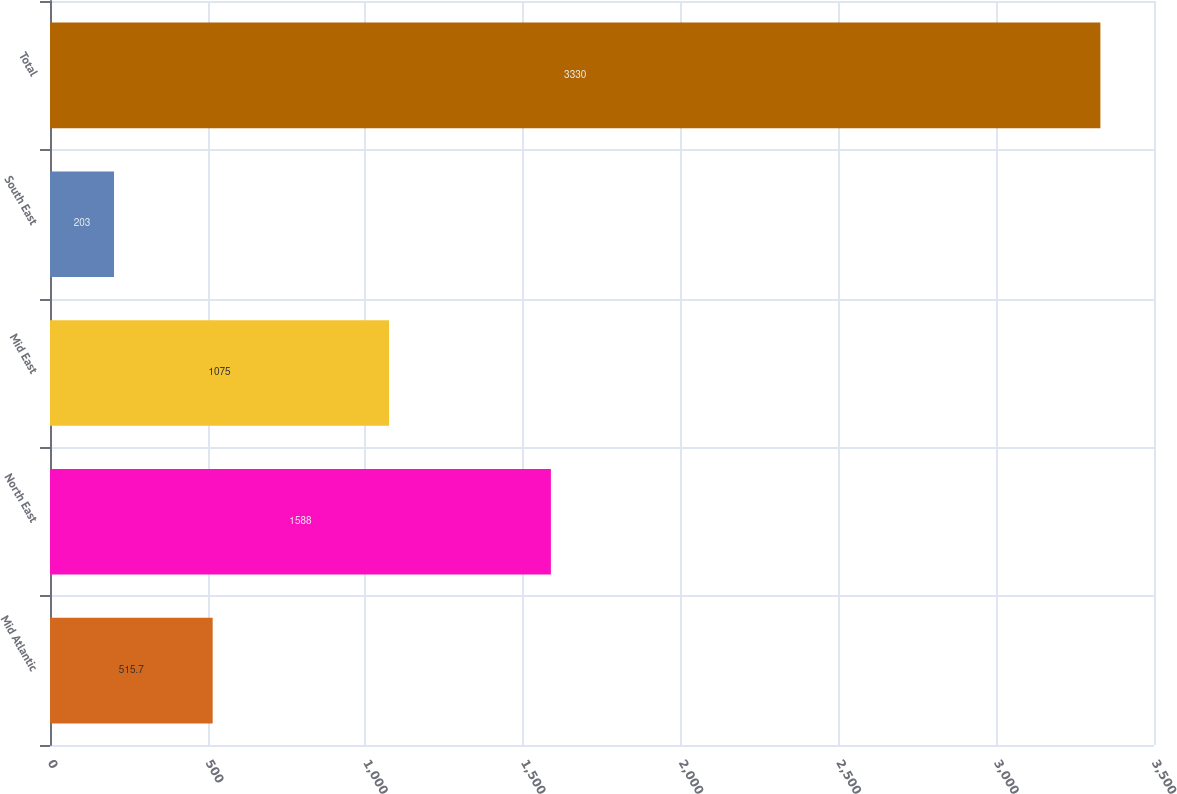<chart> <loc_0><loc_0><loc_500><loc_500><bar_chart><fcel>Mid Atlantic<fcel>North East<fcel>Mid East<fcel>South East<fcel>Total<nl><fcel>515.7<fcel>1588<fcel>1075<fcel>203<fcel>3330<nl></chart> 